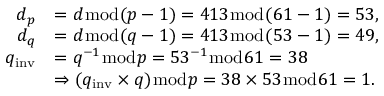<formula> <loc_0><loc_0><loc_500><loc_500>{ \begin{array} { r l } { d _ { p } } & { = d { \bmod { ( } } p - 1 ) = 4 1 3 { \bmod { ( } } 6 1 - 1 ) = 5 3 , } \\ { d _ { q } } & { = d { \bmod { ( } } q - 1 ) = 4 1 3 { \bmod { ( } } 5 3 - 1 ) = 4 9 , } \\ { q _ { i n v } } & { = q ^ { - 1 } { \bmod { p } } = 5 3 ^ { - 1 } { \bmod { 6 } } 1 = 3 8 } \\ & { \Rightarrow ( q _ { i n v } \times q ) { \bmod { p } } = 3 8 \times 5 3 { \bmod { 6 } } 1 = 1 . } \end{array} }</formula> 